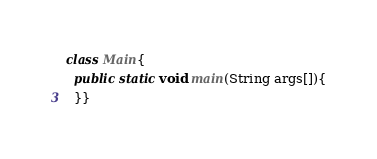Convert code to text. <code><loc_0><loc_0><loc_500><loc_500><_Java_>class Main{
  public static void main(String args[]){
  }}</code> 